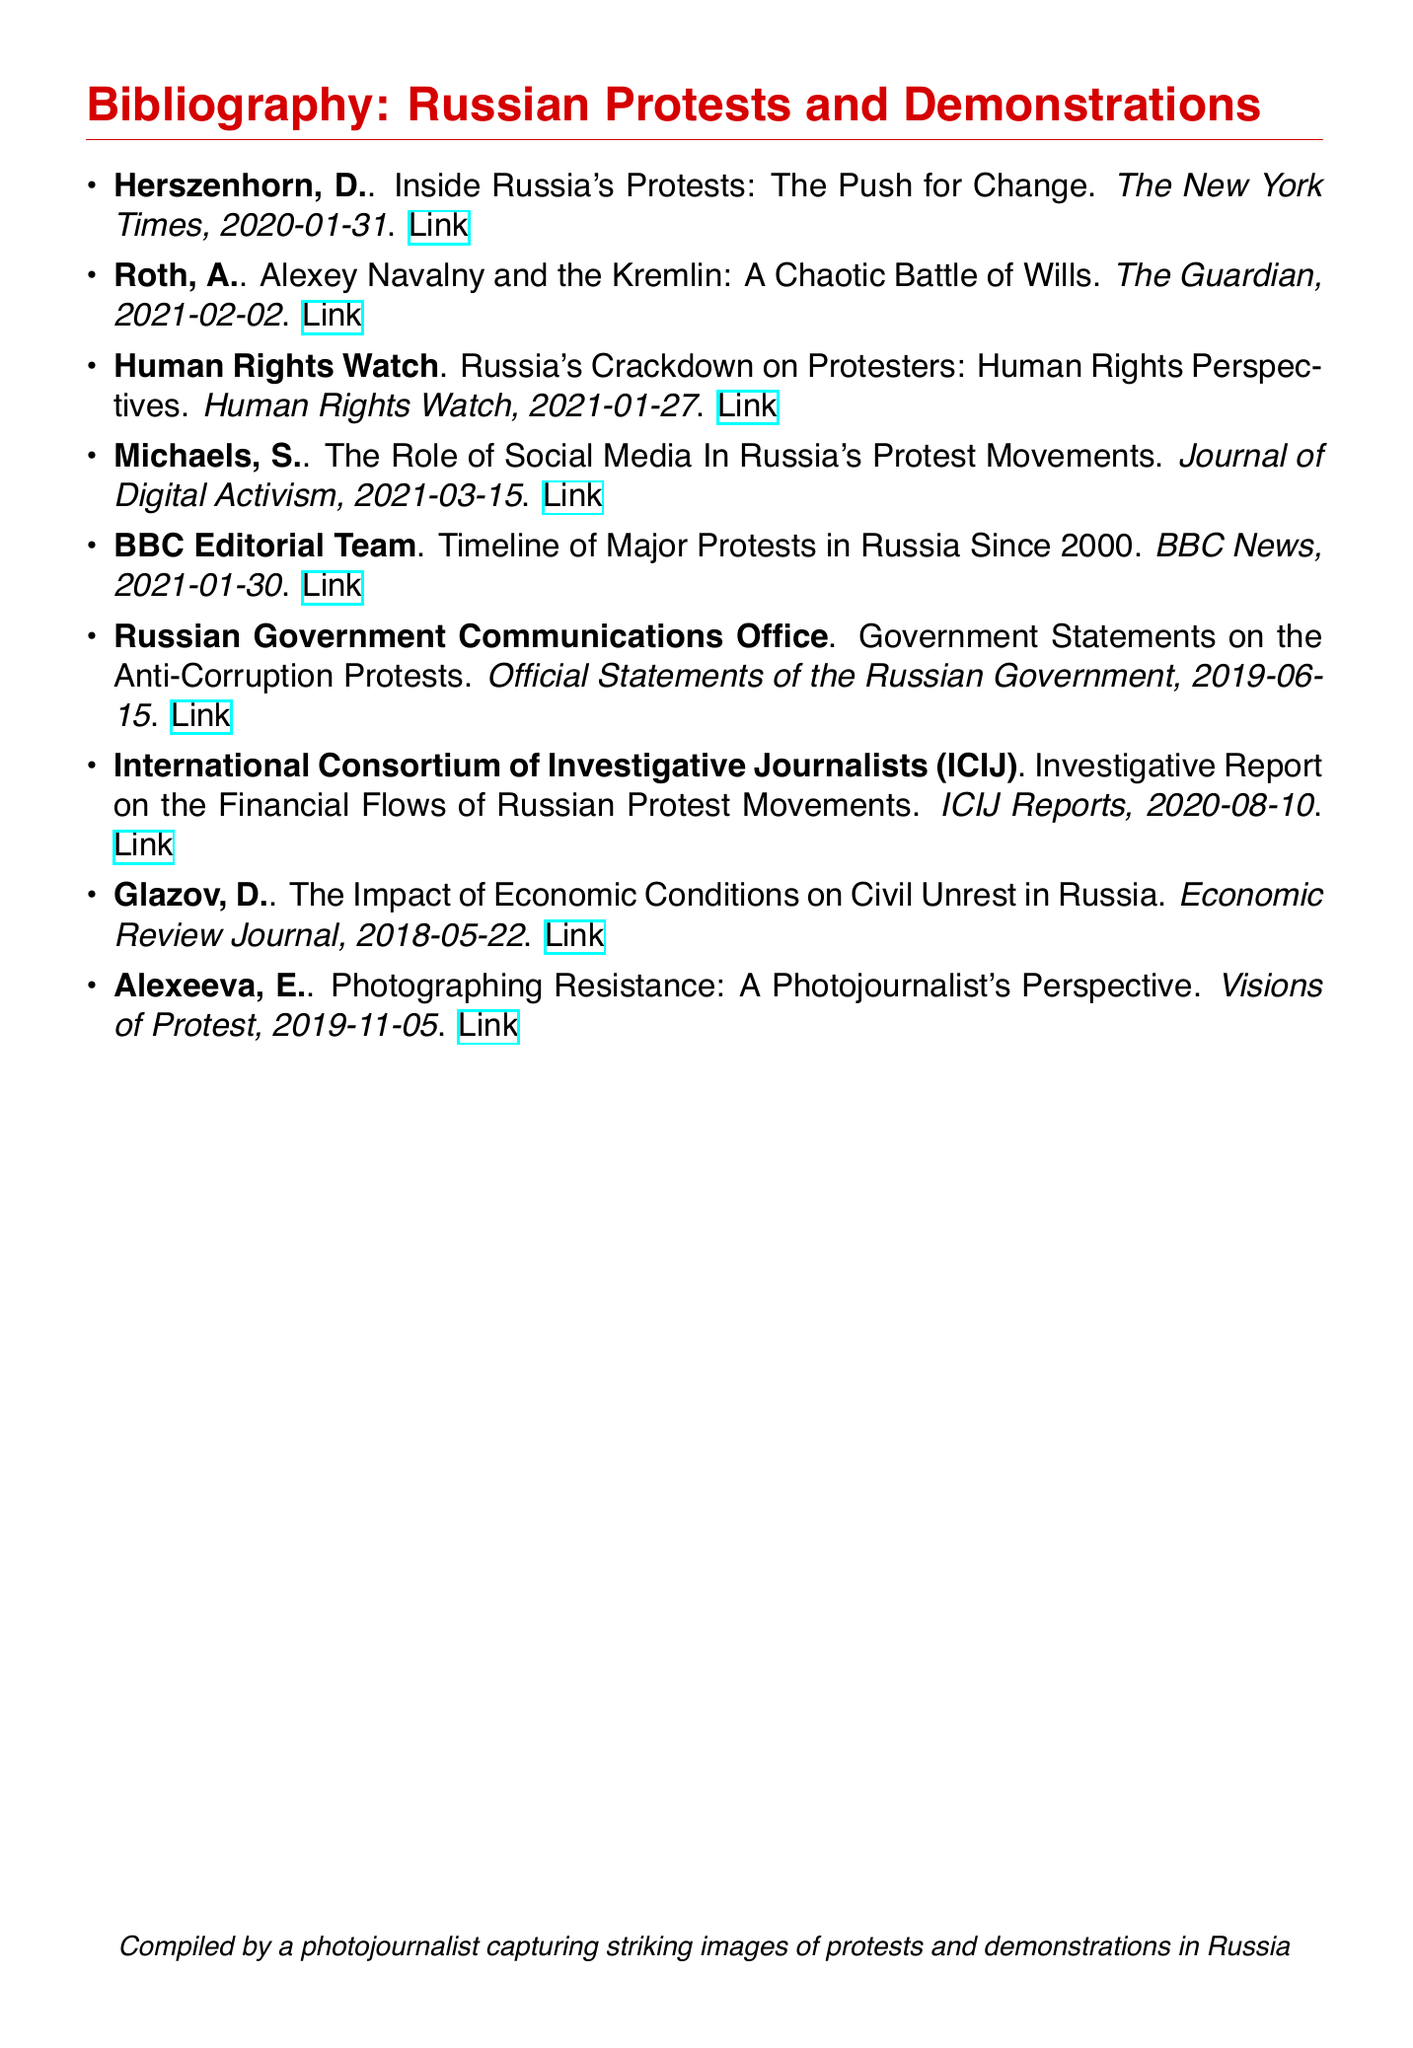What is the publication date of the article by Herszenhorn? The publication date is specified in the entry for Herszenhorn's article, which is 2020-01-31.
Answer: 2020-01-31 Who wrote the report on the financial flows of Russian protest movements? The report on financial flows was authored by the International Consortium of Investigative Journalists (ICIJ).
Answer: International Consortium of Investigative Journalists (ICIJ) What is the title of the article by Roth? The title of Roth's article is provided in the bibliography section, which is "Alexey Navalny and the Kremlin: A Chaotic Battle of Wills."
Answer: Alexey Navalny and the Kremlin: A Chaotic Battle of Wills Which organization published a report on the crackdown on protesters? The organization responsible for publishing the report on the crackdown on protesters is Human Rights Watch.
Answer: Human Rights Watch How many entries mention the year 2021? To find the number of entries mentioning the year 2021, we count the relevant entries in the document, which are three.
Answer: 3 What type of document is this bibliography classified as? The document type is indicated as a bibliography, which catalogs various sources related to specific topics.
Answer: Bibliography What is the main focus of the article by Alexeeva? Alexeeva's article is focused specifically on the perspective of a photojournalist in relation to protests, as stated in the title.
Answer: A Photojournalist's Perspective Which news organization published a timeline of major protests in Russia? The news organization that published the timeline is BBC News, as stated in the entry.
Answer: BBC News 